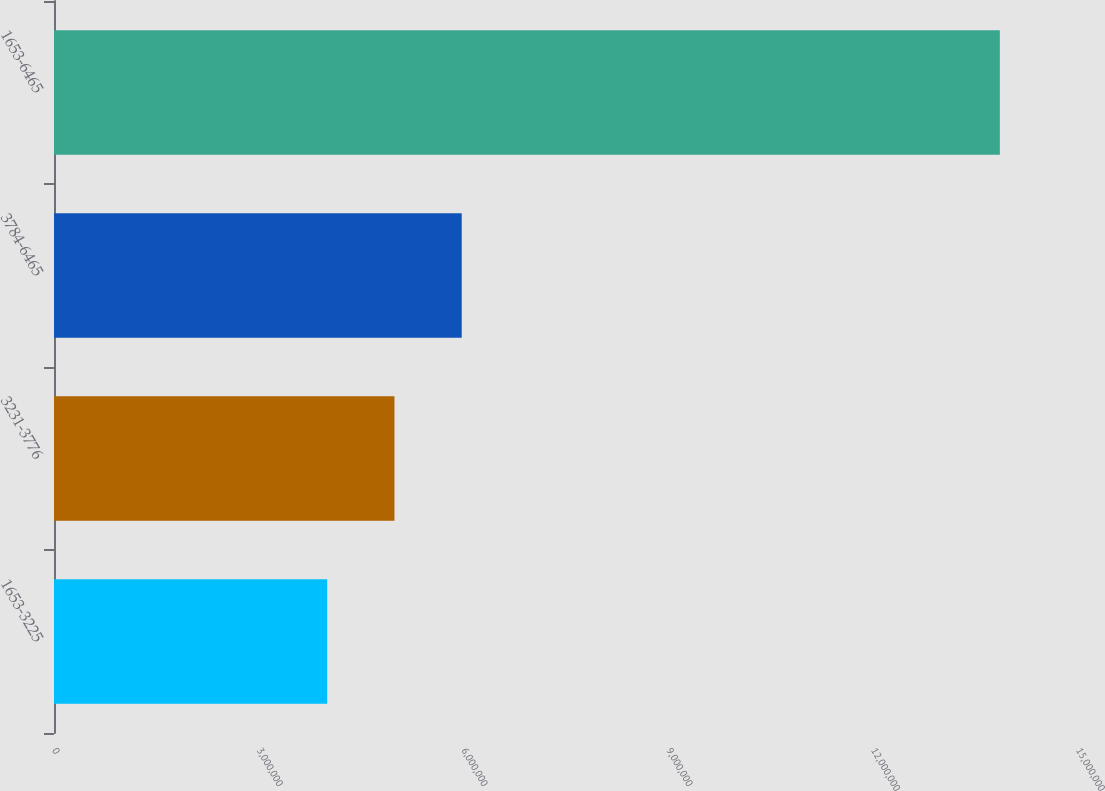Convert chart. <chart><loc_0><loc_0><loc_500><loc_500><bar_chart><fcel>1653-3225<fcel>3231-3776<fcel>3784-6465<fcel>1653-6465<nl><fcel>4.00188e+06<fcel>4.98721e+06<fcel>5.97253e+06<fcel>1.38551e+07<nl></chart> 